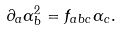<formula> <loc_0><loc_0><loc_500><loc_500>\partial _ { a } \alpha _ { b } ^ { 2 } = f _ { a b c } \alpha _ { c } .</formula> 